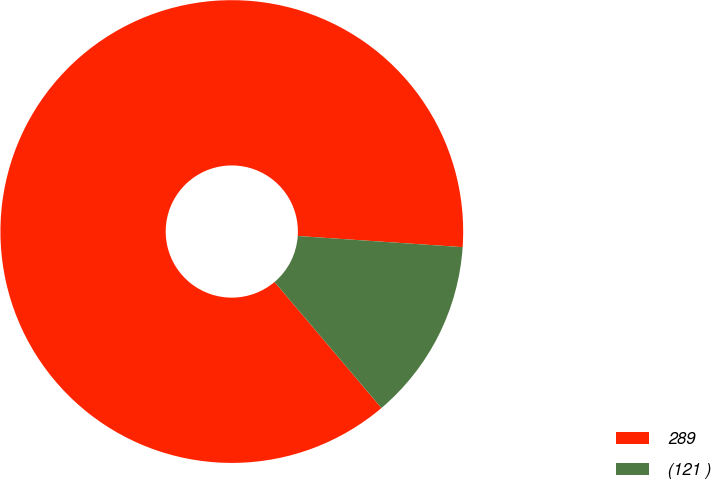Convert chart. <chart><loc_0><loc_0><loc_500><loc_500><pie_chart><fcel>289<fcel>(121 )<nl><fcel>87.27%<fcel>12.73%<nl></chart> 